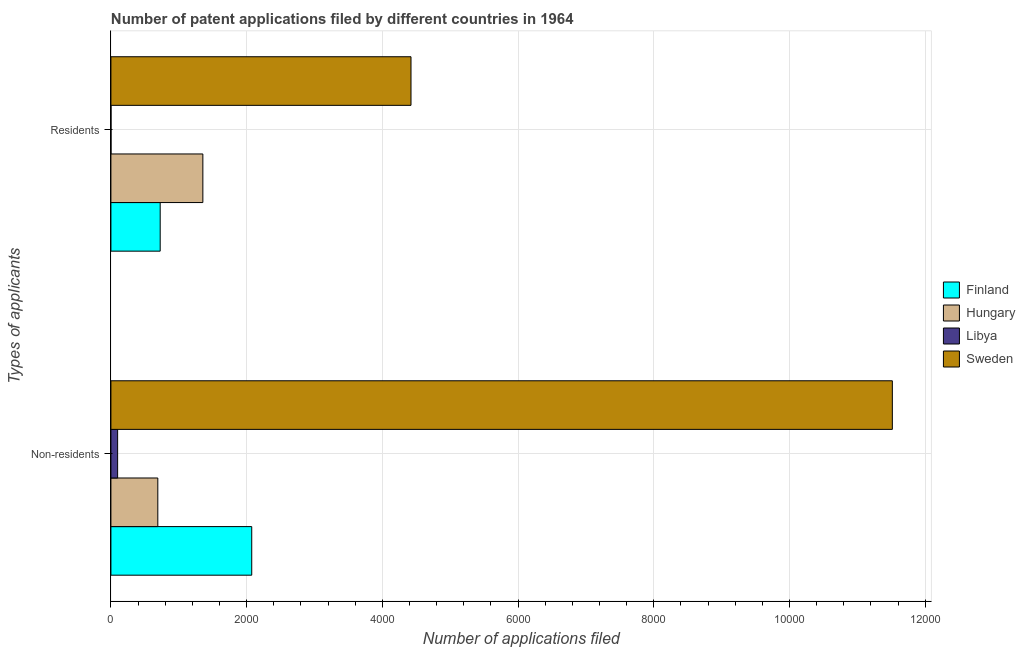How many groups of bars are there?
Offer a terse response. 2. How many bars are there on the 1st tick from the top?
Make the answer very short. 4. What is the label of the 2nd group of bars from the top?
Your answer should be very brief. Non-residents. What is the number of patent applications by non residents in Libya?
Offer a terse response. 99. Across all countries, what is the maximum number of patent applications by residents?
Ensure brevity in your answer.  4422. Across all countries, what is the minimum number of patent applications by non residents?
Give a very brief answer. 99. In which country was the number of patent applications by non residents minimum?
Give a very brief answer. Libya. What is the total number of patent applications by non residents in the graph?
Keep it short and to the point. 1.44e+04. What is the difference between the number of patent applications by residents in Finland and that in Libya?
Your answer should be very brief. 725. What is the difference between the number of patent applications by residents in Sweden and the number of patent applications by non residents in Hungary?
Offer a terse response. 3731. What is the average number of patent applications by residents per country?
Offer a terse response. 1626. What is the difference between the number of patent applications by residents and number of patent applications by non residents in Finland?
Provide a succinct answer. -1349. In how many countries, is the number of patent applications by non residents greater than 1200 ?
Make the answer very short. 2. What is the ratio of the number of patent applications by residents in Sweden to that in Hungary?
Give a very brief answer. 3.26. Is the number of patent applications by residents in Finland less than that in Libya?
Offer a very short reply. No. What does the 2nd bar from the bottom in Non-residents represents?
Make the answer very short. Hungary. Are all the bars in the graph horizontal?
Provide a succinct answer. Yes. What is the difference between two consecutive major ticks on the X-axis?
Provide a short and direct response. 2000. How are the legend labels stacked?
Keep it short and to the point. Vertical. What is the title of the graph?
Give a very brief answer. Number of patent applications filed by different countries in 1964. Does "Zambia" appear as one of the legend labels in the graph?
Provide a short and direct response. No. What is the label or title of the X-axis?
Offer a very short reply. Number of applications filed. What is the label or title of the Y-axis?
Offer a terse response. Types of applicants. What is the Number of applications filed in Finland in Non-residents?
Offer a very short reply. 2075. What is the Number of applications filed of Hungary in Non-residents?
Keep it short and to the point. 691. What is the Number of applications filed in Libya in Non-residents?
Ensure brevity in your answer.  99. What is the Number of applications filed of Sweden in Non-residents?
Provide a short and direct response. 1.15e+04. What is the Number of applications filed of Finland in Residents?
Offer a terse response. 726. What is the Number of applications filed in Hungary in Residents?
Provide a short and direct response. 1355. What is the Number of applications filed of Libya in Residents?
Provide a succinct answer. 1. What is the Number of applications filed of Sweden in Residents?
Your response must be concise. 4422. Across all Types of applicants, what is the maximum Number of applications filed in Finland?
Ensure brevity in your answer.  2075. Across all Types of applicants, what is the maximum Number of applications filed in Hungary?
Offer a terse response. 1355. Across all Types of applicants, what is the maximum Number of applications filed in Libya?
Your answer should be very brief. 99. Across all Types of applicants, what is the maximum Number of applications filed of Sweden?
Provide a short and direct response. 1.15e+04. Across all Types of applicants, what is the minimum Number of applications filed in Finland?
Provide a short and direct response. 726. Across all Types of applicants, what is the minimum Number of applications filed of Hungary?
Offer a very short reply. 691. Across all Types of applicants, what is the minimum Number of applications filed of Sweden?
Offer a terse response. 4422. What is the total Number of applications filed of Finland in the graph?
Keep it short and to the point. 2801. What is the total Number of applications filed of Hungary in the graph?
Offer a very short reply. 2046. What is the total Number of applications filed of Sweden in the graph?
Your answer should be very brief. 1.59e+04. What is the difference between the Number of applications filed of Finland in Non-residents and that in Residents?
Offer a very short reply. 1349. What is the difference between the Number of applications filed in Hungary in Non-residents and that in Residents?
Offer a terse response. -664. What is the difference between the Number of applications filed in Libya in Non-residents and that in Residents?
Make the answer very short. 98. What is the difference between the Number of applications filed in Sweden in Non-residents and that in Residents?
Ensure brevity in your answer.  7093. What is the difference between the Number of applications filed of Finland in Non-residents and the Number of applications filed of Hungary in Residents?
Your answer should be very brief. 720. What is the difference between the Number of applications filed in Finland in Non-residents and the Number of applications filed in Libya in Residents?
Your answer should be compact. 2074. What is the difference between the Number of applications filed in Finland in Non-residents and the Number of applications filed in Sweden in Residents?
Make the answer very short. -2347. What is the difference between the Number of applications filed in Hungary in Non-residents and the Number of applications filed in Libya in Residents?
Offer a very short reply. 690. What is the difference between the Number of applications filed in Hungary in Non-residents and the Number of applications filed in Sweden in Residents?
Offer a very short reply. -3731. What is the difference between the Number of applications filed of Libya in Non-residents and the Number of applications filed of Sweden in Residents?
Keep it short and to the point. -4323. What is the average Number of applications filed in Finland per Types of applicants?
Your answer should be compact. 1400.5. What is the average Number of applications filed in Hungary per Types of applicants?
Your response must be concise. 1023. What is the average Number of applications filed of Libya per Types of applicants?
Provide a succinct answer. 50. What is the average Number of applications filed in Sweden per Types of applicants?
Keep it short and to the point. 7968.5. What is the difference between the Number of applications filed in Finland and Number of applications filed in Hungary in Non-residents?
Offer a very short reply. 1384. What is the difference between the Number of applications filed of Finland and Number of applications filed of Libya in Non-residents?
Your response must be concise. 1976. What is the difference between the Number of applications filed in Finland and Number of applications filed in Sweden in Non-residents?
Keep it short and to the point. -9440. What is the difference between the Number of applications filed in Hungary and Number of applications filed in Libya in Non-residents?
Ensure brevity in your answer.  592. What is the difference between the Number of applications filed of Hungary and Number of applications filed of Sweden in Non-residents?
Provide a succinct answer. -1.08e+04. What is the difference between the Number of applications filed of Libya and Number of applications filed of Sweden in Non-residents?
Your response must be concise. -1.14e+04. What is the difference between the Number of applications filed of Finland and Number of applications filed of Hungary in Residents?
Offer a terse response. -629. What is the difference between the Number of applications filed in Finland and Number of applications filed in Libya in Residents?
Offer a very short reply. 725. What is the difference between the Number of applications filed in Finland and Number of applications filed in Sweden in Residents?
Offer a terse response. -3696. What is the difference between the Number of applications filed in Hungary and Number of applications filed in Libya in Residents?
Your answer should be compact. 1354. What is the difference between the Number of applications filed of Hungary and Number of applications filed of Sweden in Residents?
Offer a terse response. -3067. What is the difference between the Number of applications filed of Libya and Number of applications filed of Sweden in Residents?
Give a very brief answer. -4421. What is the ratio of the Number of applications filed of Finland in Non-residents to that in Residents?
Ensure brevity in your answer.  2.86. What is the ratio of the Number of applications filed in Hungary in Non-residents to that in Residents?
Offer a very short reply. 0.51. What is the ratio of the Number of applications filed of Libya in Non-residents to that in Residents?
Provide a succinct answer. 99. What is the ratio of the Number of applications filed in Sweden in Non-residents to that in Residents?
Give a very brief answer. 2.6. What is the difference between the highest and the second highest Number of applications filed in Finland?
Keep it short and to the point. 1349. What is the difference between the highest and the second highest Number of applications filed of Hungary?
Provide a succinct answer. 664. What is the difference between the highest and the second highest Number of applications filed in Sweden?
Give a very brief answer. 7093. What is the difference between the highest and the lowest Number of applications filed of Finland?
Your response must be concise. 1349. What is the difference between the highest and the lowest Number of applications filed in Hungary?
Provide a succinct answer. 664. What is the difference between the highest and the lowest Number of applications filed of Sweden?
Provide a succinct answer. 7093. 